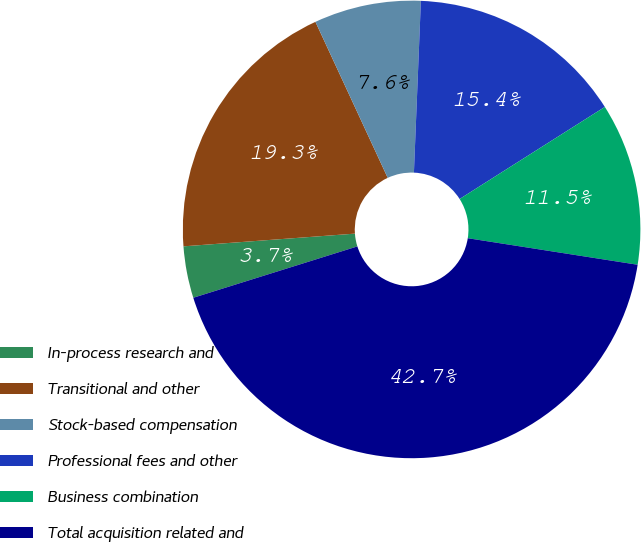Convert chart to OTSL. <chart><loc_0><loc_0><loc_500><loc_500><pie_chart><fcel>In-process research and<fcel>Transitional and other<fcel>Stock-based compensation<fcel>Professional fees and other<fcel>Business combination<fcel>Total acquisition related and<nl><fcel>3.65%<fcel>19.27%<fcel>7.55%<fcel>15.36%<fcel>11.46%<fcel>42.7%<nl></chart> 